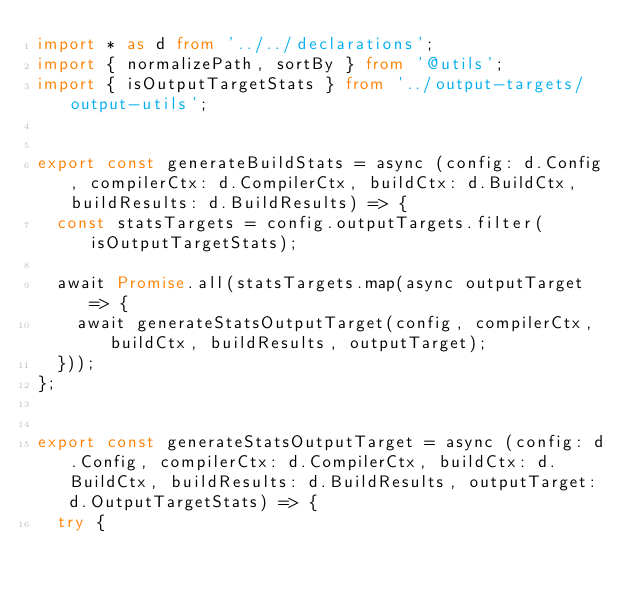<code> <loc_0><loc_0><loc_500><loc_500><_TypeScript_>import * as d from '../../declarations';
import { normalizePath, sortBy } from '@utils';
import { isOutputTargetStats } from '../output-targets/output-utils';


export const generateBuildStats = async (config: d.Config, compilerCtx: d.CompilerCtx, buildCtx: d.BuildCtx, buildResults: d.BuildResults) => {
  const statsTargets = config.outputTargets.filter(isOutputTargetStats);

  await Promise.all(statsTargets.map(async outputTarget => {
    await generateStatsOutputTarget(config, compilerCtx, buildCtx, buildResults, outputTarget);
  }));
};


export const generateStatsOutputTarget = async (config: d.Config, compilerCtx: d.CompilerCtx, buildCtx: d.BuildCtx, buildResults: d.BuildResults, outputTarget: d.OutputTargetStats) => {
  try {</code> 